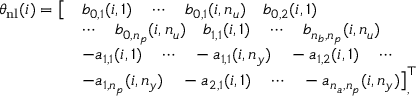<formula> <loc_0><loc_0><loc_500><loc_500>\begin{array} { r l } { \theta _ { n l } ( i ) = \left [ } & { b _ { 0 , 1 } ( i , 1 ) \quad \cdots \quad b _ { 0 , 1 } ( i , n _ { u } ) \quad b _ { 0 , 2 } ( i , 1 ) \quad } \\ & { \cdots \quad b _ { 0 , n _ { p } } ( i , n _ { u } ) \quad b _ { 1 , 1 } ( i , 1 ) \quad \cdots \quad b _ { n _ { b } , n _ { p } } ( i , n _ { u } ) } \\ & { - a _ { 1 , 1 } ( i , 1 ) \quad \cdots \quad - a _ { 1 , 1 } ( i , n _ { y } ) \quad - a _ { 1 , 2 } ( i , 1 ) \quad \cdots \quad } \\ & { - a _ { 1 , n _ { p } } ( i , n _ { y } ) \quad - a _ { 2 , 1 } ( i , 1 ) \quad \cdots \quad - a _ { n _ { a } , n _ { p } } ( i , n _ { y } ) \right ] _ { , } ^ { \top } } \end{array}</formula> 